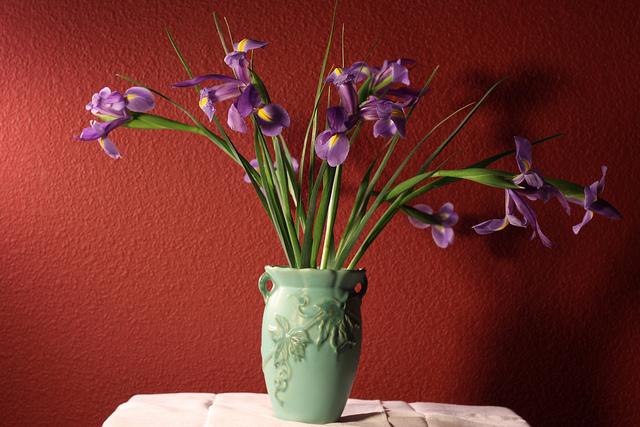Is the vase modern?
Short answer required. Yes. What kind of flowers are these?
Give a very brief answer. Violets. What pattern is on the vase?
Quick response, please. Flowers. 